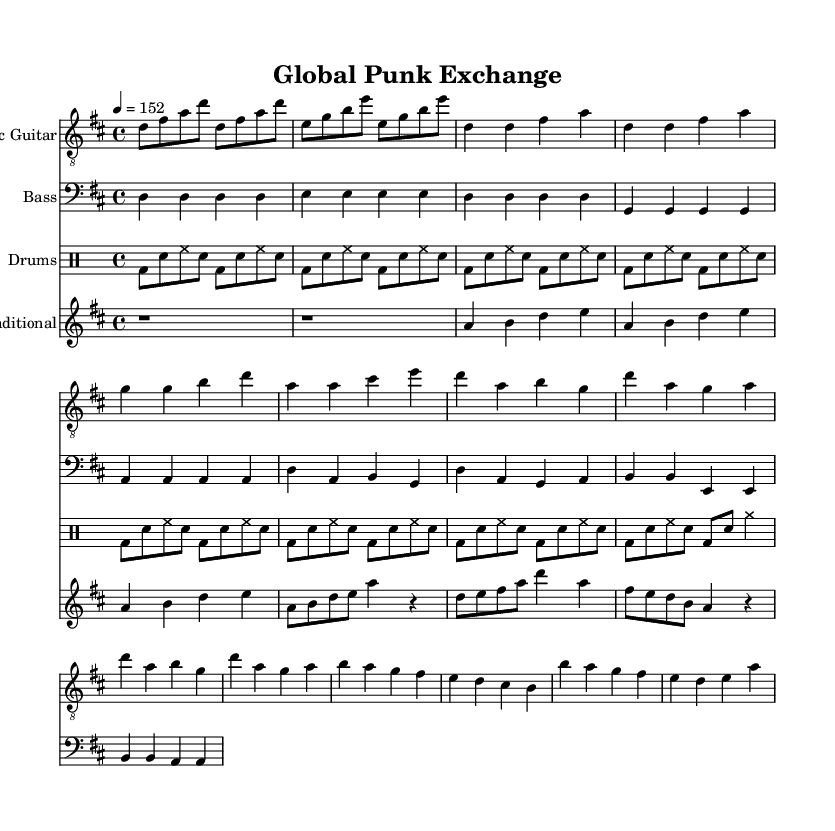What is the key signature of this music? The key signature is D major, which contains two sharps (F# and C#). This can be identified by looking for the sharp symbols at the beginning of the staff.
Answer: D major What is the time signature of this music? The time signature is 4/4, meaning there are four beats in each measure, and the quarter note gets one beat. This is indicated at the beginning of the score.
Answer: 4/4 What is the tempo marking for this piece? The tempo is marked as 4 equals 152, indicating a fast pace where a quarter note is played at a speed of 152 beats per minute. This is noted at the beginning of the score as well.
Answer: 152 How many measures does the traditional instrument part have before it plays the melody? The traditional instrument part has two measures of rest (indicated by 'r1') before it starts playing the melody. This can be seen at the beginning of that part.
Answer: 2 What is the primary rhythmic pattern used in the drum part? The primary rhythm in the drum part consists of a kick drum followed by a snare and hi-hat pattern repeated throughout. Each measure features a consistent alternating pattern of bass drum and snare with hi-hat hits.
Answer: Bass and snare pattern What type of scales does the traditional melody seem to be based on? The traditional melody is simplified and appears to be pentatonic-inspired, indicating it likely uses a five-note scale common in various folk traditions. This can be inferred from the sequences of notes played in the melody.
Answer: Pentatonic How does the electric guitar part primarily contrast the bass guitar part? The electric guitar part mainly plays higher pitched chords and melody lines, while the bass guitar primarily plays the root notes and follows a lower range pattern. This contrast in pitch and role can be observed visually across the respective staves.
Answer: Higher vs. lower pitch 